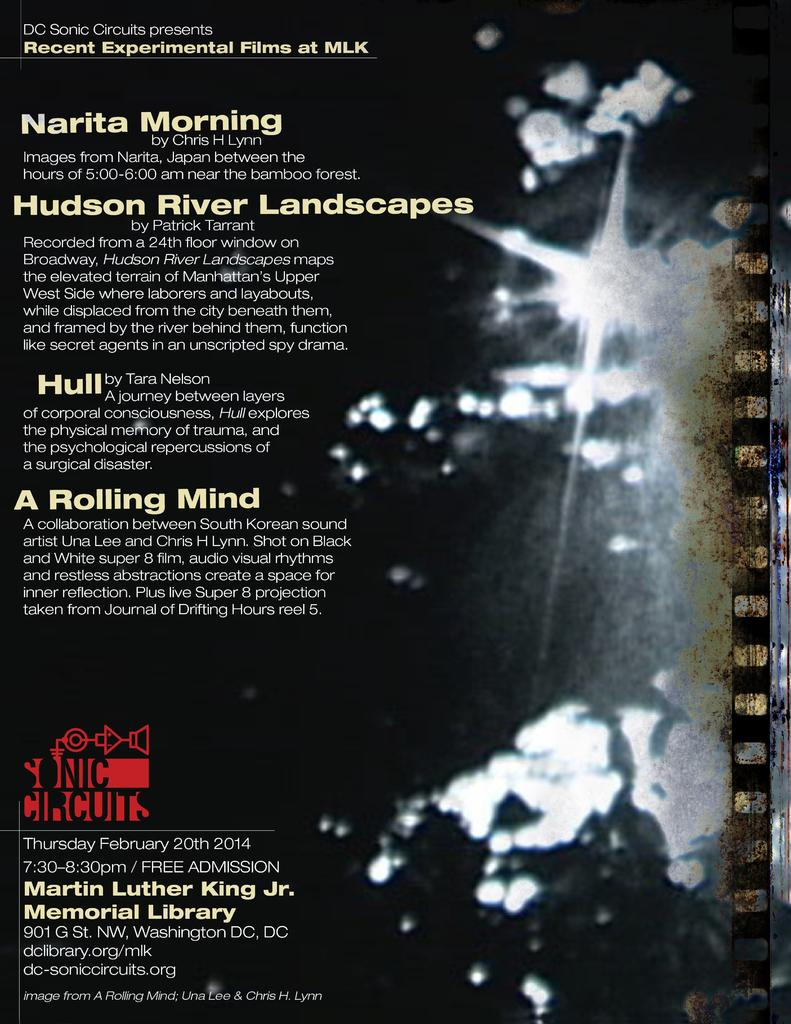<image>
Write a terse but informative summary of the picture. A flyer for the Hudson River Landscapes. and the MLK Jr. Library. 